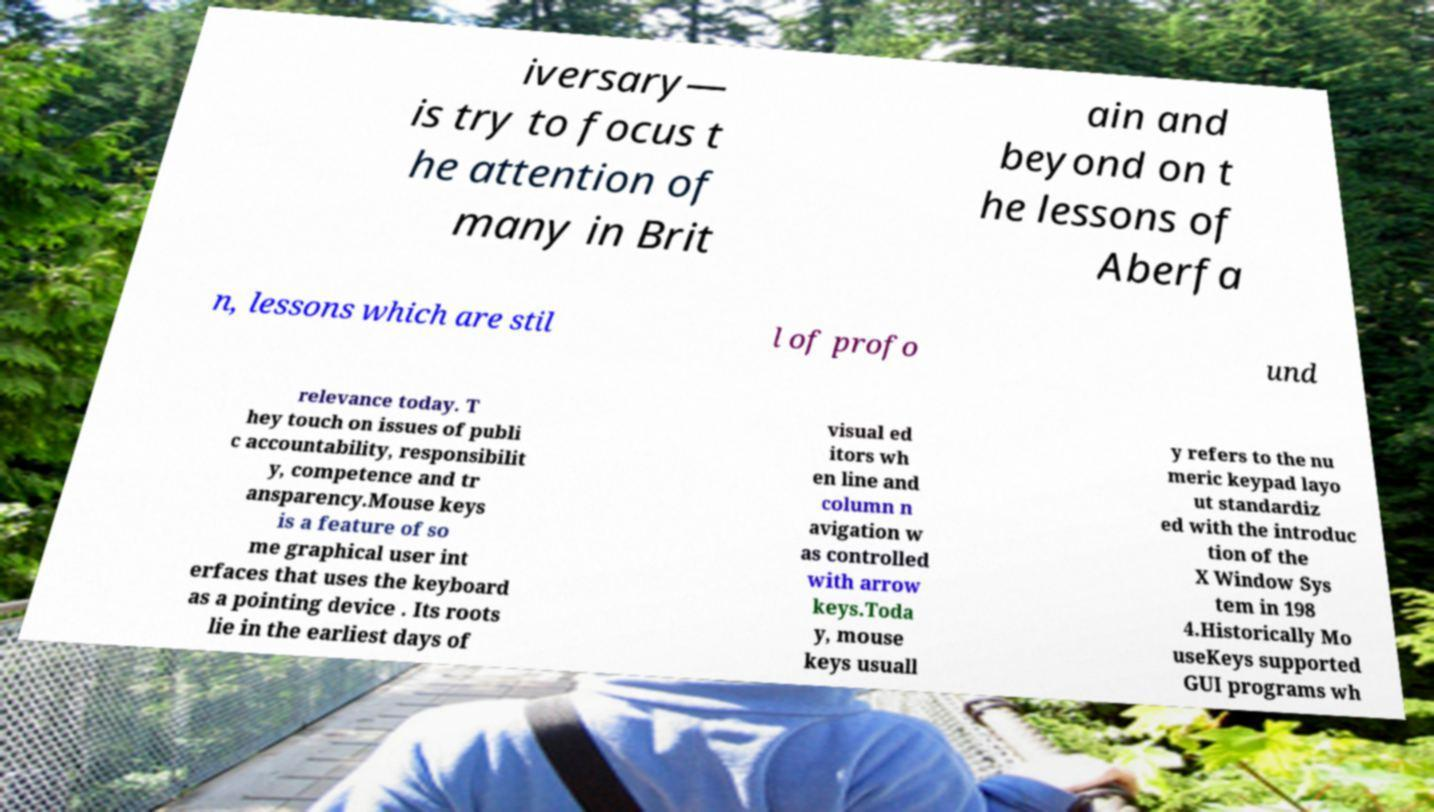Could you extract and type out the text from this image? iversary— is try to focus t he attention of many in Brit ain and beyond on t he lessons of Aberfa n, lessons which are stil l of profo und relevance today. T hey touch on issues of publi c accountability, responsibilit y, competence and tr ansparency.Mouse keys is a feature of so me graphical user int erfaces that uses the keyboard as a pointing device . Its roots lie in the earliest days of visual ed itors wh en line and column n avigation w as controlled with arrow keys.Toda y, mouse keys usuall y refers to the nu meric keypad layo ut standardiz ed with the introduc tion of the X Window Sys tem in 198 4.Historically Mo useKeys supported GUI programs wh 